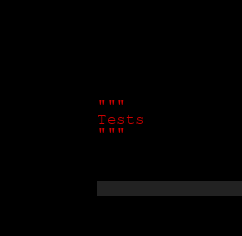<code> <loc_0><loc_0><loc_500><loc_500><_Python_>"""
Tests
"""
</code> 